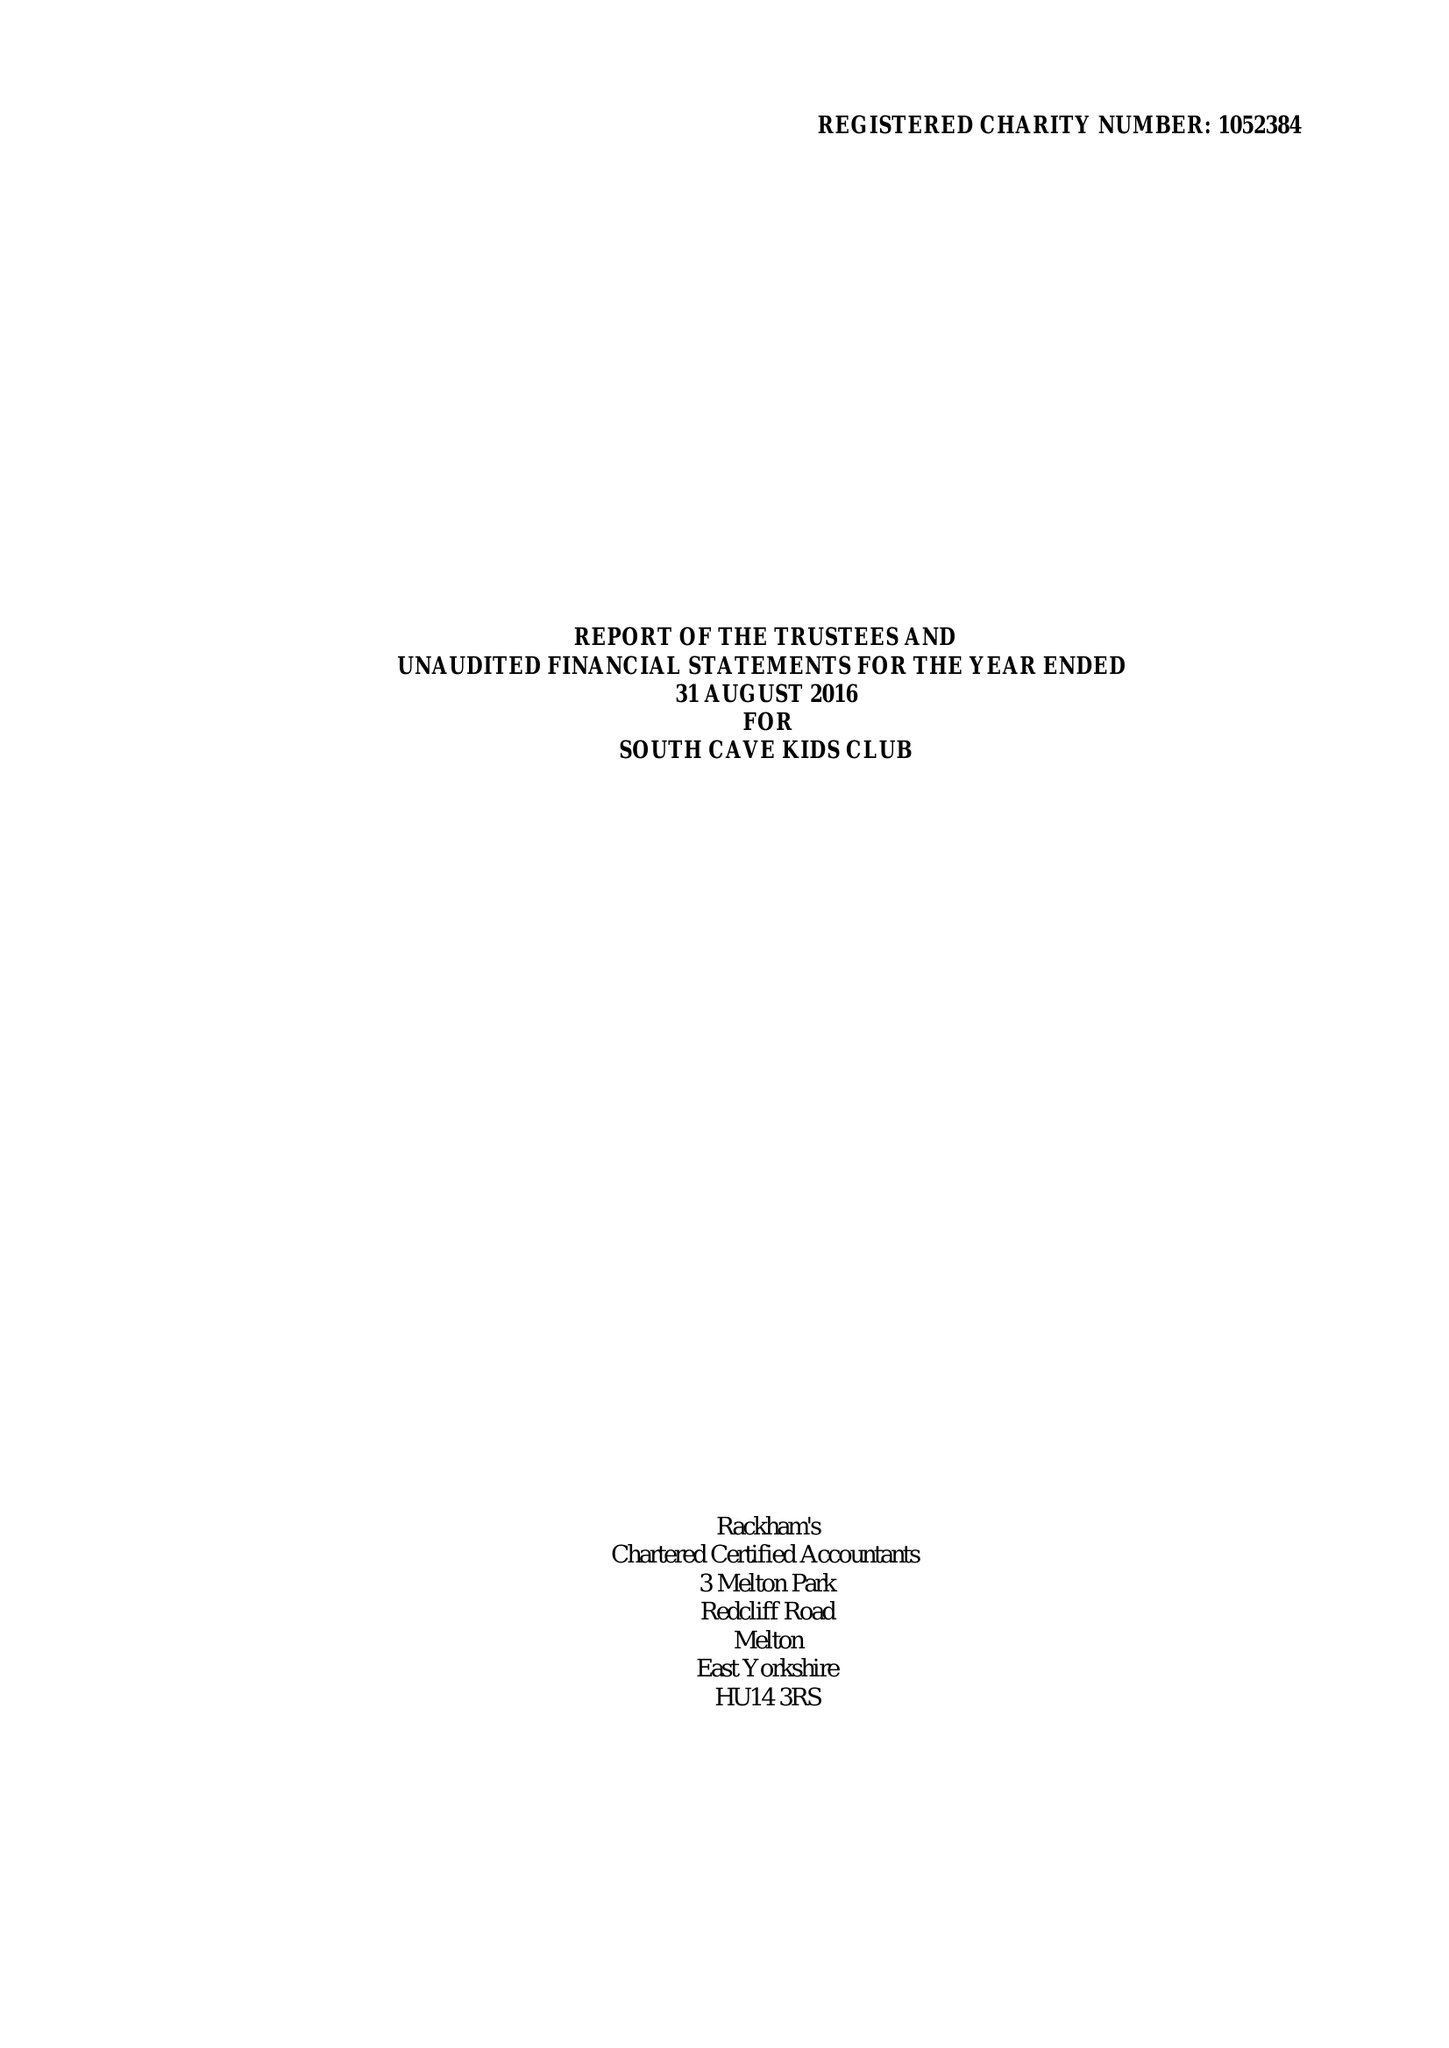What is the value for the address__post_town?
Answer the question using a single word or phrase. BROUGH 